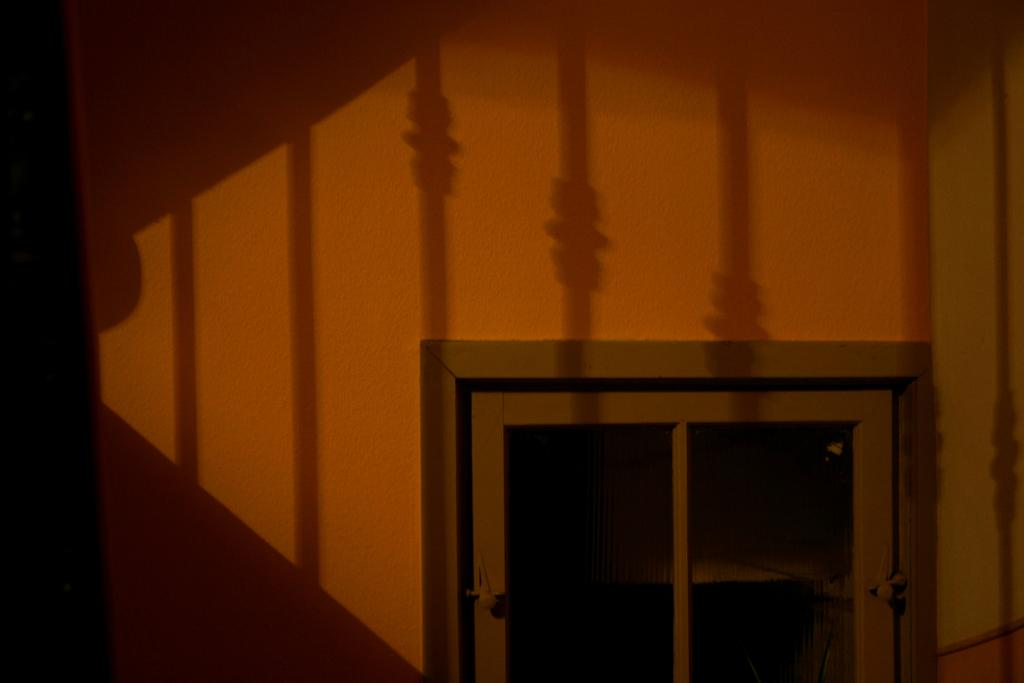What type of structure can be seen in the image? There is a wall in the image. Is there any entrance visible in the image? Yes, there is a door in the image. How many boats are docked near the wall in the image? There are no boats present in the image; it only features a wall and a door. What type of needle is being used to sew the wall in the image? There is no needle or sewing activity depicted in the image; it only shows a wall and a door. 